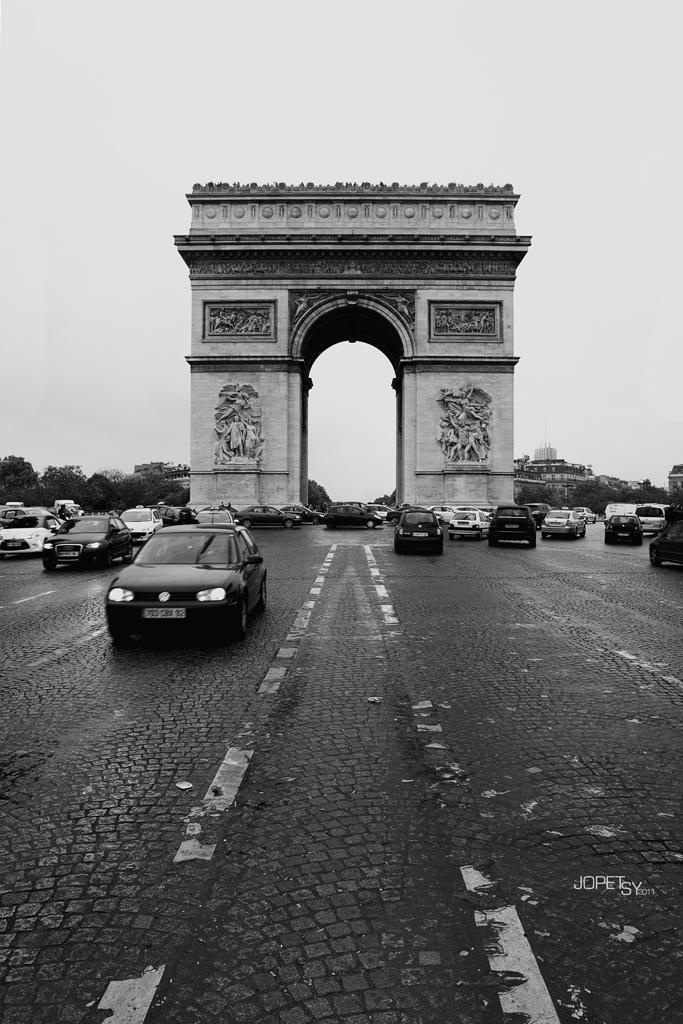Can you describe this image briefly? In this picture there are vehicles on the road and there is a monument. At the back there are trees and buildings. At the top there is sky. At the bottom there is a road. At the bottom right there is a text. 